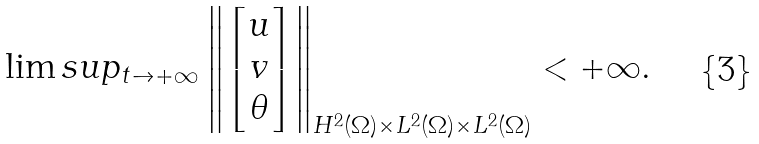<formula> <loc_0><loc_0><loc_500><loc_500>\lim s u p _ { t \to + \infty } \left \| \begin{bmatrix} u \\ v \\ \theta \end{bmatrix} \right \| _ { H ^ { 2 } ( \Omega ) \times L ^ { 2 } ( \Omega ) \times L ^ { 2 } ( \Omega ) } < + \infty .</formula> 